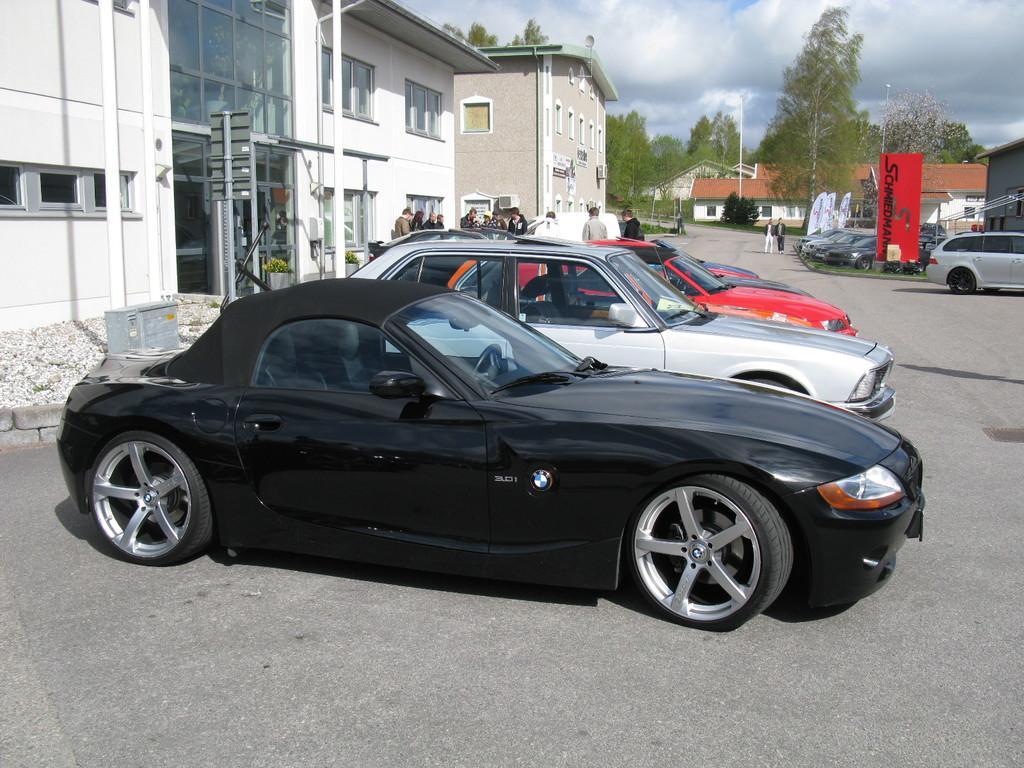Could you give a brief overview of what you see in this image? This image consists of many cars parked on the road. In the front, there is a black car. At the bottom, there is a road. On the left, there are buildings. In the background, we can see the houses and trees. On the right, there are cars and a board in red color. At the top, there are clouds in the sky. 